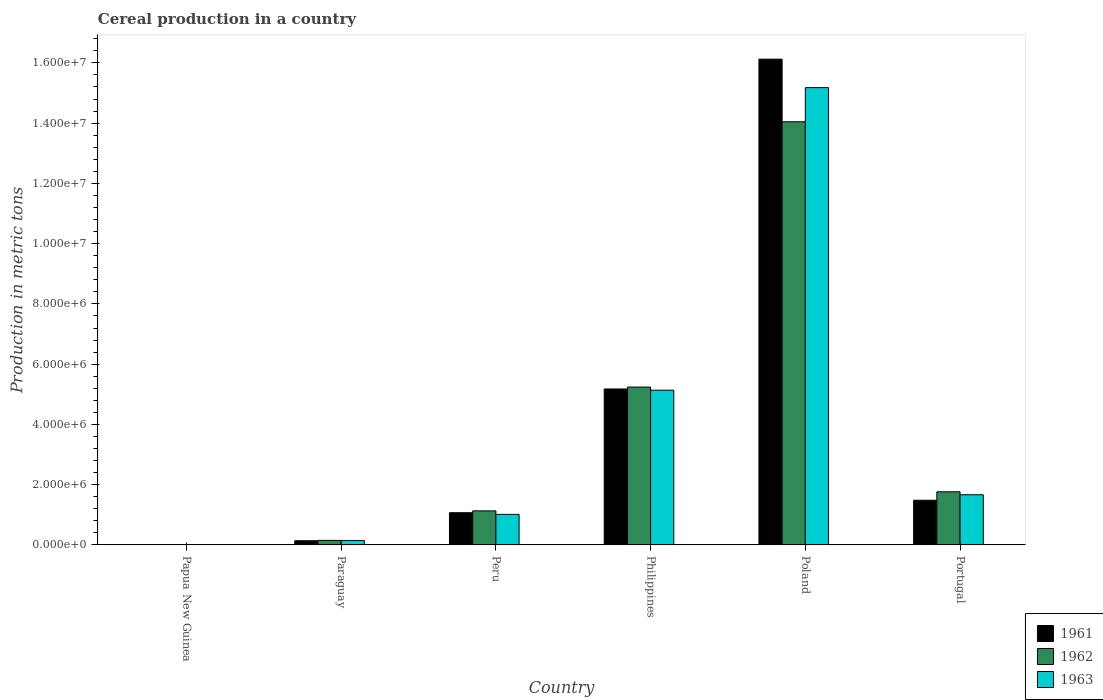Are the number of bars on each tick of the X-axis equal?
Ensure brevity in your answer.  Yes. What is the label of the 1st group of bars from the left?
Keep it short and to the point. Papua New Guinea. In how many cases, is the number of bars for a given country not equal to the number of legend labels?
Ensure brevity in your answer.  0. What is the total cereal production in 1962 in Paraguay?
Provide a short and direct response. 1.51e+05. Across all countries, what is the maximum total cereal production in 1963?
Provide a succinct answer. 1.52e+07. Across all countries, what is the minimum total cereal production in 1962?
Your response must be concise. 1891. In which country was the total cereal production in 1961 minimum?
Your answer should be compact. Papua New Guinea. What is the total total cereal production in 1962 in the graph?
Offer a very short reply. 2.23e+07. What is the difference between the total cereal production in 1963 in Paraguay and that in Portugal?
Offer a very short reply. -1.52e+06. What is the difference between the total cereal production in 1962 in Philippines and the total cereal production in 1963 in Poland?
Give a very brief answer. -9.94e+06. What is the average total cereal production in 1962 per country?
Provide a succinct answer. 3.72e+06. What is the difference between the total cereal production of/in 1961 and total cereal production of/in 1963 in Peru?
Your response must be concise. 5.57e+04. What is the ratio of the total cereal production in 1961 in Paraguay to that in Poland?
Your answer should be compact. 0.01. What is the difference between the highest and the second highest total cereal production in 1963?
Your answer should be very brief. 1.35e+07. What is the difference between the highest and the lowest total cereal production in 1961?
Your response must be concise. 1.61e+07. Is the sum of the total cereal production in 1961 in Poland and Portugal greater than the maximum total cereal production in 1963 across all countries?
Your response must be concise. Yes. What does the 1st bar from the left in Philippines represents?
Offer a terse response. 1961. What does the 1st bar from the right in Paraguay represents?
Give a very brief answer. 1963. How many bars are there?
Keep it short and to the point. 18. What is the difference between two consecutive major ticks on the Y-axis?
Your answer should be compact. 2.00e+06. Are the values on the major ticks of Y-axis written in scientific E-notation?
Ensure brevity in your answer.  Yes. Where does the legend appear in the graph?
Your response must be concise. Bottom right. How are the legend labels stacked?
Keep it short and to the point. Vertical. What is the title of the graph?
Give a very brief answer. Cereal production in a country. Does "1967" appear as one of the legend labels in the graph?
Ensure brevity in your answer.  No. What is the label or title of the X-axis?
Make the answer very short. Country. What is the label or title of the Y-axis?
Ensure brevity in your answer.  Production in metric tons. What is the Production in metric tons in 1961 in Papua New Guinea?
Give a very brief answer. 1850. What is the Production in metric tons in 1962 in Papua New Guinea?
Ensure brevity in your answer.  1891. What is the Production in metric tons of 1963 in Papua New Guinea?
Your answer should be very brief. 1871. What is the Production in metric tons of 1961 in Paraguay?
Your answer should be compact. 1.40e+05. What is the Production in metric tons of 1962 in Paraguay?
Your answer should be compact. 1.51e+05. What is the Production in metric tons in 1963 in Paraguay?
Offer a very short reply. 1.48e+05. What is the Production in metric tons in 1961 in Peru?
Provide a succinct answer. 1.07e+06. What is the Production in metric tons of 1962 in Peru?
Your answer should be compact. 1.13e+06. What is the Production in metric tons of 1963 in Peru?
Provide a succinct answer. 1.01e+06. What is the Production in metric tons in 1961 in Philippines?
Your response must be concise. 5.18e+06. What is the Production in metric tons in 1962 in Philippines?
Offer a terse response. 5.24e+06. What is the Production in metric tons of 1963 in Philippines?
Make the answer very short. 5.14e+06. What is the Production in metric tons of 1961 in Poland?
Provide a succinct answer. 1.61e+07. What is the Production in metric tons in 1962 in Poland?
Your answer should be compact. 1.40e+07. What is the Production in metric tons in 1963 in Poland?
Give a very brief answer. 1.52e+07. What is the Production in metric tons in 1961 in Portugal?
Give a very brief answer. 1.48e+06. What is the Production in metric tons of 1962 in Portugal?
Offer a terse response. 1.76e+06. What is the Production in metric tons of 1963 in Portugal?
Make the answer very short. 1.67e+06. Across all countries, what is the maximum Production in metric tons in 1961?
Provide a succinct answer. 1.61e+07. Across all countries, what is the maximum Production in metric tons of 1962?
Offer a terse response. 1.40e+07. Across all countries, what is the maximum Production in metric tons of 1963?
Keep it short and to the point. 1.52e+07. Across all countries, what is the minimum Production in metric tons in 1961?
Your answer should be compact. 1850. Across all countries, what is the minimum Production in metric tons of 1962?
Offer a terse response. 1891. Across all countries, what is the minimum Production in metric tons in 1963?
Provide a short and direct response. 1871. What is the total Production in metric tons in 1961 in the graph?
Your response must be concise. 2.40e+07. What is the total Production in metric tons of 1962 in the graph?
Offer a terse response. 2.23e+07. What is the total Production in metric tons of 1963 in the graph?
Keep it short and to the point. 2.31e+07. What is the difference between the Production in metric tons in 1961 in Papua New Guinea and that in Paraguay?
Provide a short and direct response. -1.38e+05. What is the difference between the Production in metric tons in 1962 in Papua New Guinea and that in Paraguay?
Provide a succinct answer. -1.49e+05. What is the difference between the Production in metric tons of 1963 in Papua New Guinea and that in Paraguay?
Your answer should be very brief. -1.46e+05. What is the difference between the Production in metric tons of 1961 in Papua New Guinea and that in Peru?
Your answer should be very brief. -1.07e+06. What is the difference between the Production in metric tons of 1962 in Papua New Guinea and that in Peru?
Your answer should be very brief. -1.13e+06. What is the difference between the Production in metric tons of 1963 in Papua New Guinea and that in Peru?
Give a very brief answer. -1.01e+06. What is the difference between the Production in metric tons in 1961 in Papua New Guinea and that in Philippines?
Offer a terse response. -5.17e+06. What is the difference between the Production in metric tons of 1962 in Papua New Guinea and that in Philippines?
Your answer should be compact. -5.24e+06. What is the difference between the Production in metric tons in 1963 in Papua New Guinea and that in Philippines?
Ensure brevity in your answer.  -5.13e+06. What is the difference between the Production in metric tons in 1961 in Papua New Guinea and that in Poland?
Keep it short and to the point. -1.61e+07. What is the difference between the Production in metric tons of 1962 in Papua New Guinea and that in Poland?
Provide a succinct answer. -1.40e+07. What is the difference between the Production in metric tons in 1963 in Papua New Guinea and that in Poland?
Your answer should be compact. -1.52e+07. What is the difference between the Production in metric tons of 1961 in Papua New Guinea and that in Portugal?
Provide a short and direct response. -1.48e+06. What is the difference between the Production in metric tons of 1962 in Papua New Guinea and that in Portugal?
Give a very brief answer. -1.76e+06. What is the difference between the Production in metric tons of 1963 in Papua New Guinea and that in Portugal?
Your response must be concise. -1.66e+06. What is the difference between the Production in metric tons in 1961 in Paraguay and that in Peru?
Your answer should be compact. -9.30e+05. What is the difference between the Production in metric tons in 1962 in Paraguay and that in Peru?
Your response must be concise. -9.80e+05. What is the difference between the Production in metric tons in 1963 in Paraguay and that in Peru?
Make the answer very short. -8.67e+05. What is the difference between the Production in metric tons of 1961 in Paraguay and that in Philippines?
Provide a short and direct response. -5.04e+06. What is the difference between the Production in metric tons of 1962 in Paraguay and that in Philippines?
Offer a very short reply. -5.09e+06. What is the difference between the Production in metric tons of 1963 in Paraguay and that in Philippines?
Your response must be concise. -4.99e+06. What is the difference between the Production in metric tons of 1961 in Paraguay and that in Poland?
Provide a short and direct response. -1.60e+07. What is the difference between the Production in metric tons in 1962 in Paraguay and that in Poland?
Offer a very short reply. -1.39e+07. What is the difference between the Production in metric tons of 1963 in Paraguay and that in Poland?
Ensure brevity in your answer.  -1.50e+07. What is the difference between the Production in metric tons in 1961 in Paraguay and that in Portugal?
Ensure brevity in your answer.  -1.34e+06. What is the difference between the Production in metric tons of 1962 in Paraguay and that in Portugal?
Offer a very short reply. -1.61e+06. What is the difference between the Production in metric tons in 1963 in Paraguay and that in Portugal?
Offer a terse response. -1.52e+06. What is the difference between the Production in metric tons of 1961 in Peru and that in Philippines?
Ensure brevity in your answer.  -4.11e+06. What is the difference between the Production in metric tons of 1962 in Peru and that in Philippines?
Keep it short and to the point. -4.11e+06. What is the difference between the Production in metric tons of 1963 in Peru and that in Philippines?
Offer a very short reply. -4.12e+06. What is the difference between the Production in metric tons in 1961 in Peru and that in Poland?
Ensure brevity in your answer.  -1.51e+07. What is the difference between the Production in metric tons of 1962 in Peru and that in Poland?
Make the answer very short. -1.29e+07. What is the difference between the Production in metric tons in 1963 in Peru and that in Poland?
Provide a short and direct response. -1.42e+07. What is the difference between the Production in metric tons in 1961 in Peru and that in Portugal?
Your answer should be very brief. -4.13e+05. What is the difference between the Production in metric tons of 1962 in Peru and that in Portugal?
Your response must be concise. -6.33e+05. What is the difference between the Production in metric tons in 1963 in Peru and that in Portugal?
Give a very brief answer. -6.51e+05. What is the difference between the Production in metric tons of 1961 in Philippines and that in Poland?
Provide a succinct answer. -1.09e+07. What is the difference between the Production in metric tons in 1962 in Philippines and that in Poland?
Your answer should be very brief. -8.81e+06. What is the difference between the Production in metric tons of 1963 in Philippines and that in Poland?
Offer a terse response. -1.00e+07. What is the difference between the Production in metric tons in 1961 in Philippines and that in Portugal?
Provide a succinct answer. 3.69e+06. What is the difference between the Production in metric tons in 1962 in Philippines and that in Portugal?
Make the answer very short. 3.48e+06. What is the difference between the Production in metric tons of 1963 in Philippines and that in Portugal?
Offer a very short reply. 3.47e+06. What is the difference between the Production in metric tons in 1961 in Poland and that in Portugal?
Provide a succinct answer. 1.46e+07. What is the difference between the Production in metric tons in 1962 in Poland and that in Portugal?
Offer a terse response. 1.23e+07. What is the difference between the Production in metric tons in 1963 in Poland and that in Portugal?
Your response must be concise. 1.35e+07. What is the difference between the Production in metric tons in 1961 in Papua New Guinea and the Production in metric tons in 1962 in Paraguay?
Provide a succinct answer. -1.49e+05. What is the difference between the Production in metric tons in 1961 in Papua New Guinea and the Production in metric tons in 1963 in Paraguay?
Make the answer very short. -1.46e+05. What is the difference between the Production in metric tons in 1962 in Papua New Guinea and the Production in metric tons in 1963 in Paraguay?
Keep it short and to the point. -1.46e+05. What is the difference between the Production in metric tons of 1961 in Papua New Guinea and the Production in metric tons of 1962 in Peru?
Make the answer very short. -1.13e+06. What is the difference between the Production in metric tons in 1961 in Papua New Guinea and the Production in metric tons in 1963 in Peru?
Your answer should be compact. -1.01e+06. What is the difference between the Production in metric tons in 1962 in Papua New Guinea and the Production in metric tons in 1963 in Peru?
Your answer should be very brief. -1.01e+06. What is the difference between the Production in metric tons of 1961 in Papua New Guinea and the Production in metric tons of 1962 in Philippines?
Give a very brief answer. -5.24e+06. What is the difference between the Production in metric tons in 1961 in Papua New Guinea and the Production in metric tons in 1963 in Philippines?
Offer a very short reply. -5.13e+06. What is the difference between the Production in metric tons of 1962 in Papua New Guinea and the Production in metric tons of 1963 in Philippines?
Give a very brief answer. -5.13e+06. What is the difference between the Production in metric tons of 1961 in Papua New Guinea and the Production in metric tons of 1962 in Poland?
Offer a terse response. -1.40e+07. What is the difference between the Production in metric tons of 1961 in Papua New Guinea and the Production in metric tons of 1963 in Poland?
Ensure brevity in your answer.  -1.52e+07. What is the difference between the Production in metric tons of 1962 in Papua New Guinea and the Production in metric tons of 1963 in Poland?
Keep it short and to the point. -1.52e+07. What is the difference between the Production in metric tons in 1961 in Papua New Guinea and the Production in metric tons in 1962 in Portugal?
Offer a very short reply. -1.76e+06. What is the difference between the Production in metric tons in 1961 in Papua New Guinea and the Production in metric tons in 1963 in Portugal?
Make the answer very short. -1.66e+06. What is the difference between the Production in metric tons in 1962 in Papua New Guinea and the Production in metric tons in 1963 in Portugal?
Your response must be concise. -1.66e+06. What is the difference between the Production in metric tons in 1961 in Paraguay and the Production in metric tons in 1962 in Peru?
Provide a short and direct response. -9.91e+05. What is the difference between the Production in metric tons in 1961 in Paraguay and the Production in metric tons in 1963 in Peru?
Make the answer very short. -8.75e+05. What is the difference between the Production in metric tons in 1962 in Paraguay and the Production in metric tons in 1963 in Peru?
Ensure brevity in your answer.  -8.64e+05. What is the difference between the Production in metric tons in 1961 in Paraguay and the Production in metric tons in 1962 in Philippines?
Provide a short and direct response. -5.10e+06. What is the difference between the Production in metric tons of 1961 in Paraguay and the Production in metric tons of 1963 in Philippines?
Keep it short and to the point. -5.00e+06. What is the difference between the Production in metric tons of 1962 in Paraguay and the Production in metric tons of 1963 in Philippines?
Give a very brief answer. -4.98e+06. What is the difference between the Production in metric tons in 1961 in Paraguay and the Production in metric tons in 1962 in Poland?
Provide a short and direct response. -1.39e+07. What is the difference between the Production in metric tons of 1961 in Paraguay and the Production in metric tons of 1963 in Poland?
Provide a succinct answer. -1.50e+07. What is the difference between the Production in metric tons of 1962 in Paraguay and the Production in metric tons of 1963 in Poland?
Offer a very short reply. -1.50e+07. What is the difference between the Production in metric tons in 1961 in Paraguay and the Production in metric tons in 1962 in Portugal?
Your response must be concise. -1.62e+06. What is the difference between the Production in metric tons in 1961 in Paraguay and the Production in metric tons in 1963 in Portugal?
Your answer should be compact. -1.53e+06. What is the difference between the Production in metric tons in 1962 in Paraguay and the Production in metric tons in 1963 in Portugal?
Your answer should be very brief. -1.51e+06. What is the difference between the Production in metric tons in 1961 in Peru and the Production in metric tons in 1962 in Philippines?
Provide a short and direct response. -4.17e+06. What is the difference between the Production in metric tons in 1961 in Peru and the Production in metric tons in 1963 in Philippines?
Make the answer very short. -4.07e+06. What is the difference between the Production in metric tons of 1962 in Peru and the Production in metric tons of 1963 in Philippines?
Give a very brief answer. -4.00e+06. What is the difference between the Production in metric tons of 1961 in Peru and the Production in metric tons of 1962 in Poland?
Give a very brief answer. -1.30e+07. What is the difference between the Production in metric tons in 1961 in Peru and the Production in metric tons in 1963 in Poland?
Offer a very short reply. -1.41e+07. What is the difference between the Production in metric tons in 1962 in Peru and the Production in metric tons in 1963 in Poland?
Offer a terse response. -1.40e+07. What is the difference between the Production in metric tons in 1961 in Peru and the Production in metric tons in 1962 in Portugal?
Your answer should be compact. -6.94e+05. What is the difference between the Production in metric tons of 1961 in Peru and the Production in metric tons of 1963 in Portugal?
Ensure brevity in your answer.  -5.95e+05. What is the difference between the Production in metric tons in 1962 in Peru and the Production in metric tons in 1963 in Portugal?
Your answer should be very brief. -5.35e+05. What is the difference between the Production in metric tons of 1961 in Philippines and the Production in metric tons of 1962 in Poland?
Offer a terse response. -8.87e+06. What is the difference between the Production in metric tons in 1961 in Philippines and the Production in metric tons in 1963 in Poland?
Offer a terse response. -1.00e+07. What is the difference between the Production in metric tons in 1962 in Philippines and the Production in metric tons in 1963 in Poland?
Ensure brevity in your answer.  -9.94e+06. What is the difference between the Production in metric tons in 1961 in Philippines and the Production in metric tons in 1962 in Portugal?
Your response must be concise. 3.41e+06. What is the difference between the Production in metric tons in 1961 in Philippines and the Production in metric tons in 1963 in Portugal?
Offer a terse response. 3.51e+06. What is the difference between the Production in metric tons in 1962 in Philippines and the Production in metric tons in 1963 in Portugal?
Make the answer very short. 3.57e+06. What is the difference between the Production in metric tons of 1961 in Poland and the Production in metric tons of 1962 in Portugal?
Keep it short and to the point. 1.44e+07. What is the difference between the Production in metric tons in 1961 in Poland and the Production in metric tons in 1963 in Portugal?
Make the answer very short. 1.45e+07. What is the difference between the Production in metric tons of 1962 in Poland and the Production in metric tons of 1963 in Portugal?
Make the answer very short. 1.24e+07. What is the average Production in metric tons in 1961 per country?
Make the answer very short. 4.00e+06. What is the average Production in metric tons in 1962 per country?
Your answer should be very brief. 3.72e+06. What is the average Production in metric tons in 1963 per country?
Ensure brevity in your answer.  3.86e+06. What is the difference between the Production in metric tons in 1961 and Production in metric tons in 1962 in Papua New Guinea?
Offer a very short reply. -41. What is the difference between the Production in metric tons in 1961 and Production in metric tons in 1963 in Papua New Guinea?
Your answer should be very brief. -21. What is the difference between the Production in metric tons of 1961 and Production in metric tons of 1962 in Paraguay?
Offer a very short reply. -1.11e+04. What is the difference between the Production in metric tons in 1961 and Production in metric tons in 1963 in Paraguay?
Offer a very short reply. -8100. What is the difference between the Production in metric tons of 1962 and Production in metric tons of 1963 in Paraguay?
Give a very brief answer. 3000. What is the difference between the Production in metric tons of 1961 and Production in metric tons of 1962 in Peru?
Keep it short and to the point. -6.05e+04. What is the difference between the Production in metric tons of 1961 and Production in metric tons of 1963 in Peru?
Ensure brevity in your answer.  5.57e+04. What is the difference between the Production in metric tons in 1962 and Production in metric tons in 1963 in Peru?
Keep it short and to the point. 1.16e+05. What is the difference between the Production in metric tons of 1961 and Production in metric tons of 1962 in Philippines?
Make the answer very short. -6.35e+04. What is the difference between the Production in metric tons of 1961 and Production in metric tons of 1963 in Philippines?
Provide a succinct answer. 4.08e+04. What is the difference between the Production in metric tons in 1962 and Production in metric tons in 1963 in Philippines?
Your answer should be very brief. 1.04e+05. What is the difference between the Production in metric tons of 1961 and Production in metric tons of 1962 in Poland?
Offer a very short reply. 2.08e+06. What is the difference between the Production in metric tons in 1961 and Production in metric tons in 1963 in Poland?
Your answer should be very brief. 9.45e+05. What is the difference between the Production in metric tons in 1962 and Production in metric tons in 1963 in Poland?
Offer a terse response. -1.13e+06. What is the difference between the Production in metric tons of 1961 and Production in metric tons of 1962 in Portugal?
Offer a terse response. -2.81e+05. What is the difference between the Production in metric tons in 1961 and Production in metric tons in 1963 in Portugal?
Your answer should be compact. -1.82e+05. What is the difference between the Production in metric tons of 1962 and Production in metric tons of 1963 in Portugal?
Provide a succinct answer. 9.87e+04. What is the ratio of the Production in metric tons of 1961 in Papua New Guinea to that in Paraguay?
Ensure brevity in your answer.  0.01. What is the ratio of the Production in metric tons in 1962 in Papua New Guinea to that in Paraguay?
Ensure brevity in your answer.  0.01. What is the ratio of the Production in metric tons in 1963 in Papua New Guinea to that in Paraguay?
Keep it short and to the point. 0.01. What is the ratio of the Production in metric tons of 1961 in Papua New Guinea to that in Peru?
Keep it short and to the point. 0. What is the ratio of the Production in metric tons of 1962 in Papua New Guinea to that in Peru?
Provide a short and direct response. 0. What is the ratio of the Production in metric tons of 1963 in Papua New Guinea to that in Peru?
Ensure brevity in your answer.  0. What is the ratio of the Production in metric tons in 1961 in Papua New Guinea to that in Philippines?
Keep it short and to the point. 0. What is the ratio of the Production in metric tons in 1963 in Papua New Guinea to that in Philippines?
Your answer should be compact. 0. What is the ratio of the Production in metric tons in 1962 in Papua New Guinea to that in Poland?
Your answer should be compact. 0. What is the ratio of the Production in metric tons of 1961 in Papua New Guinea to that in Portugal?
Ensure brevity in your answer.  0. What is the ratio of the Production in metric tons of 1962 in Papua New Guinea to that in Portugal?
Ensure brevity in your answer.  0. What is the ratio of the Production in metric tons of 1963 in Papua New Guinea to that in Portugal?
Give a very brief answer. 0. What is the ratio of the Production in metric tons of 1961 in Paraguay to that in Peru?
Your response must be concise. 0.13. What is the ratio of the Production in metric tons in 1962 in Paraguay to that in Peru?
Ensure brevity in your answer.  0.13. What is the ratio of the Production in metric tons of 1963 in Paraguay to that in Peru?
Offer a terse response. 0.15. What is the ratio of the Production in metric tons in 1961 in Paraguay to that in Philippines?
Your answer should be compact. 0.03. What is the ratio of the Production in metric tons in 1962 in Paraguay to that in Philippines?
Your answer should be compact. 0.03. What is the ratio of the Production in metric tons of 1963 in Paraguay to that in Philippines?
Offer a very short reply. 0.03. What is the ratio of the Production in metric tons of 1961 in Paraguay to that in Poland?
Keep it short and to the point. 0.01. What is the ratio of the Production in metric tons in 1962 in Paraguay to that in Poland?
Make the answer very short. 0.01. What is the ratio of the Production in metric tons of 1963 in Paraguay to that in Poland?
Keep it short and to the point. 0.01. What is the ratio of the Production in metric tons of 1961 in Paraguay to that in Portugal?
Give a very brief answer. 0.09. What is the ratio of the Production in metric tons in 1962 in Paraguay to that in Portugal?
Provide a succinct answer. 0.09. What is the ratio of the Production in metric tons of 1963 in Paraguay to that in Portugal?
Your answer should be compact. 0.09. What is the ratio of the Production in metric tons of 1961 in Peru to that in Philippines?
Keep it short and to the point. 0.21. What is the ratio of the Production in metric tons in 1962 in Peru to that in Philippines?
Your response must be concise. 0.22. What is the ratio of the Production in metric tons of 1963 in Peru to that in Philippines?
Offer a very short reply. 0.2. What is the ratio of the Production in metric tons of 1961 in Peru to that in Poland?
Provide a succinct answer. 0.07. What is the ratio of the Production in metric tons in 1962 in Peru to that in Poland?
Your answer should be compact. 0.08. What is the ratio of the Production in metric tons of 1963 in Peru to that in Poland?
Provide a short and direct response. 0.07. What is the ratio of the Production in metric tons in 1961 in Peru to that in Portugal?
Make the answer very short. 0.72. What is the ratio of the Production in metric tons in 1962 in Peru to that in Portugal?
Make the answer very short. 0.64. What is the ratio of the Production in metric tons in 1963 in Peru to that in Portugal?
Your answer should be compact. 0.61. What is the ratio of the Production in metric tons of 1961 in Philippines to that in Poland?
Provide a short and direct response. 0.32. What is the ratio of the Production in metric tons of 1962 in Philippines to that in Poland?
Give a very brief answer. 0.37. What is the ratio of the Production in metric tons of 1963 in Philippines to that in Poland?
Give a very brief answer. 0.34. What is the ratio of the Production in metric tons in 1961 in Philippines to that in Portugal?
Make the answer very short. 3.49. What is the ratio of the Production in metric tons of 1962 in Philippines to that in Portugal?
Keep it short and to the point. 2.97. What is the ratio of the Production in metric tons in 1963 in Philippines to that in Portugal?
Your response must be concise. 3.08. What is the ratio of the Production in metric tons in 1961 in Poland to that in Portugal?
Provide a succinct answer. 10.87. What is the ratio of the Production in metric tons of 1962 in Poland to that in Portugal?
Provide a succinct answer. 7.96. What is the ratio of the Production in metric tons of 1963 in Poland to that in Portugal?
Provide a succinct answer. 9.11. What is the difference between the highest and the second highest Production in metric tons of 1961?
Your answer should be very brief. 1.09e+07. What is the difference between the highest and the second highest Production in metric tons in 1962?
Keep it short and to the point. 8.81e+06. What is the difference between the highest and the second highest Production in metric tons of 1963?
Your answer should be compact. 1.00e+07. What is the difference between the highest and the lowest Production in metric tons in 1961?
Provide a short and direct response. 1.61e+07. What is the difference between the highest and the lowest Production in metric tons of 1962?
Your response must be concise. 1.40e+07. What is the difference between the highest and the lowest Production in metric tons of 1963?
Offer a very short reply. 1.52e+07. 